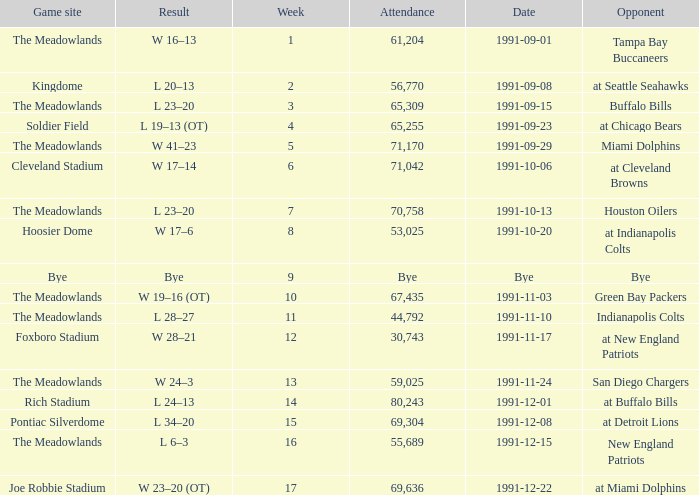What was the Attendance of the Game at Hoosier Dome? 53025.0. 